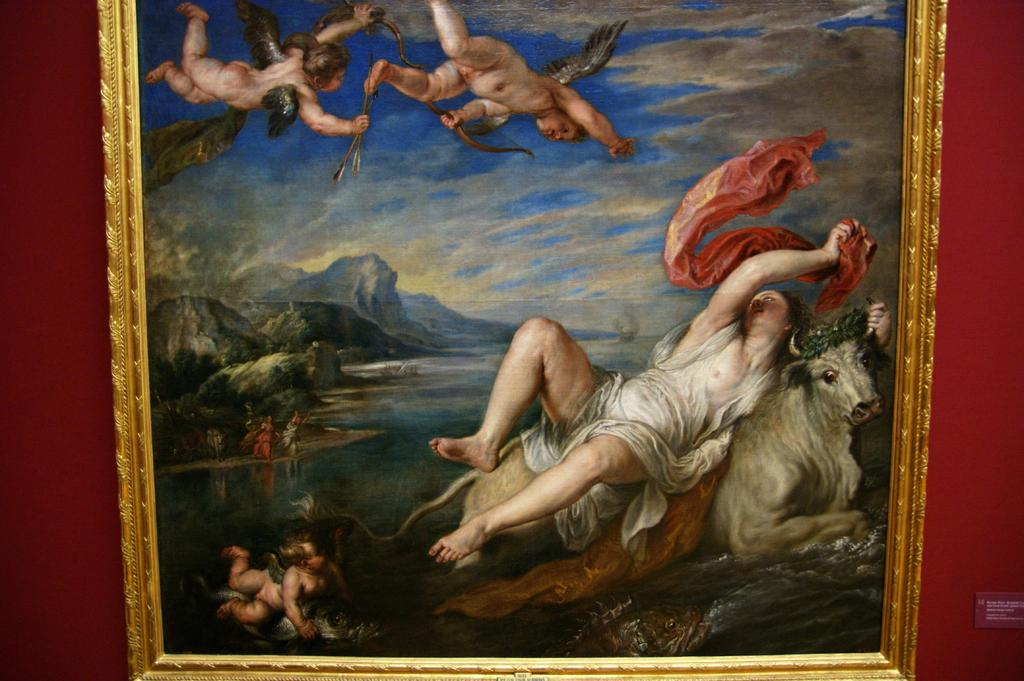What is on the wall in the image? There is a painted photo frame on the wall. Who is in the image? There is a man and two small boys in the image. What can be seen at the top of the image? The sky is visible at the top of the image. What type of chain is being held by the man in the image? There is no chain present in the image. Can you describe the bee that is buzzing around the painted photo frame? There is no bee present in the image; it only features a painted photo frame on the wall. What flavor of eggnog is being served in the image? There is no eggnog present in the image. 